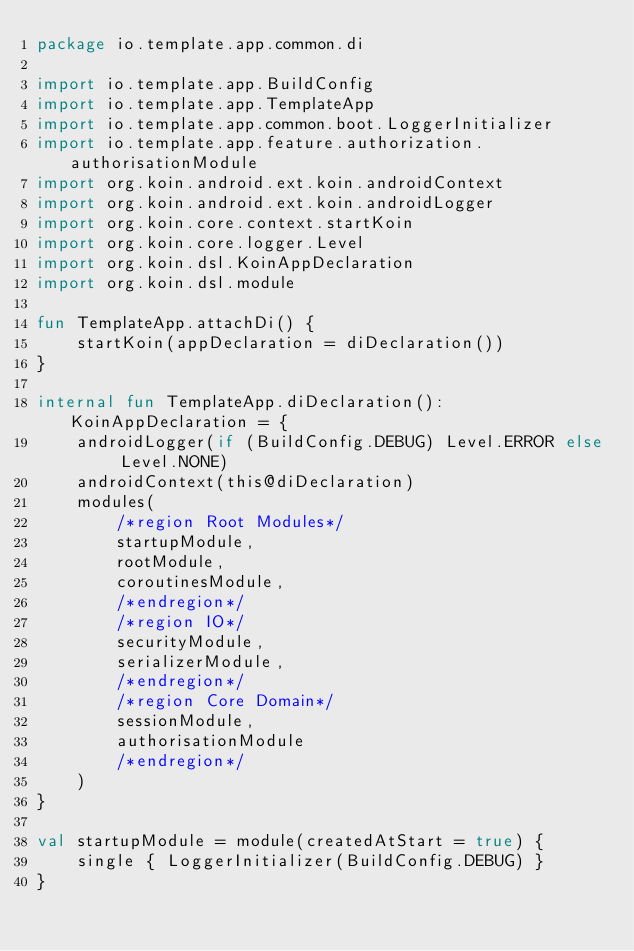<code> <loc_0><loc_0><loc_500><loc_500><_Kotlin_>package io.template.app.common.di

import io.template.app.BuildConfig
import io.template.app.TemplateApp
import io.template.app.common.boot.LoggerInitializer
import io.template.app.feature.authorization.authorisationModule
import org.koin.android.ext.koin.androidContext
import org.koin.android.ext.koin.androidLogger
import org.koin.core.context.startKoin
import org.koin.core.logger.Level
import org.koin.dsl.KoinAppDeclaration
import org.koin.dsl.module

fun TemplateApp.attachDi() {
    startKoin(appDeclaration = diDeclaration())
}

internal fun TemplateApp.diDeclaration(): KoinAppDeclaration = {
    androidLogger(if (BuildConfig.DEBUG) Level.ERROR else Level.NONE)
    androidContext(this@diDeclaration)
    modules(
        /*region Root Modules*/
        startupModule,
        rootModule,
        coroutinesModule,
        /*endregion*/
        /*region IO*/
        securityModule,
        serializerModule,
        /*endregion*/
        /*region Core Domain*/
        sessionModule,
        authorisationModule
        /*endregion*/
    )
}

val startupModule = module(createdAtStart = true) {
    single { LoggerInitializer(BuildConfig.DEBUG) }
}
</code> 